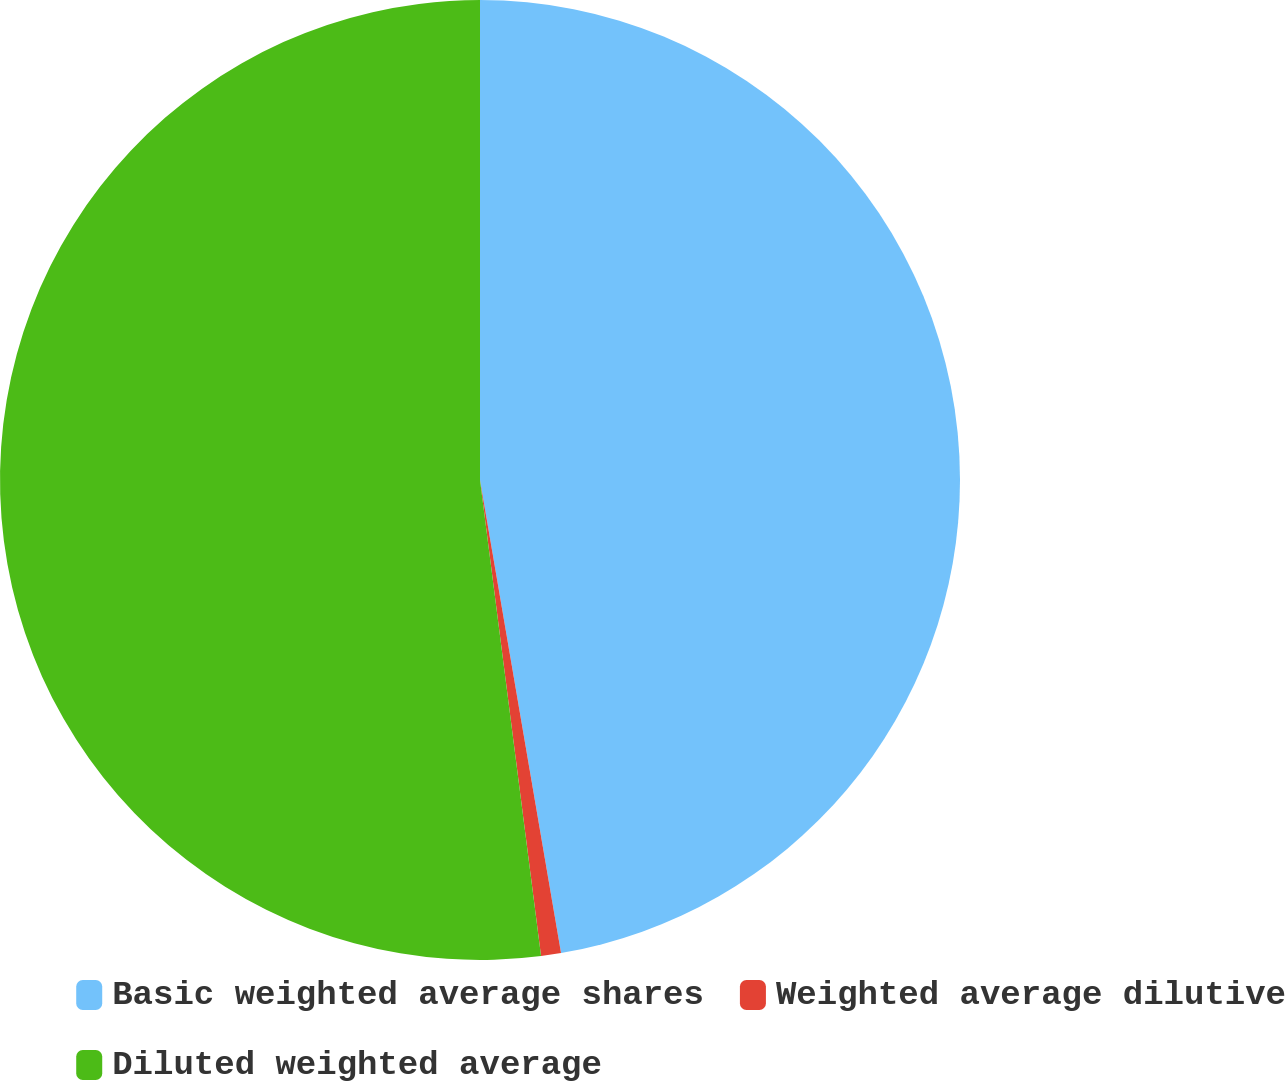Convert chart to OTSL. <chart><loc_0><loc_0><loc_500><loc_500><pie_chart><fcel>Basic weighted average shares<fcel>Weighted average dilutive<fcel>Diluted weighted average<nl><fcel>47.3%<fcel>0.67%<fcel>52.03%<nl></chart> 